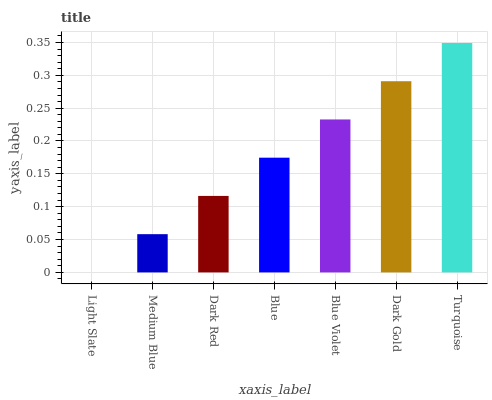Is Light Slate the minimum?
Answer yes or no. Yes. Is Turquoise the maximum?
Answer yes or no. Yes. Is Medium Blue the minimum?
Answer yes or no. No. Is Medium Blue the maximum?
Answer yes or no. No. Is Medium Blue greater than Light Slate?
Answer yes or no. Yes. Is Light Slate less than Medium Blue?
Answer yes or no. Yes. Is Light Slate greater than Medium Blue?
Answer yes or no. No. Is Medium Blue less than Light Slate?
Answer yes or no. No. Is Blue the high median?
Answer yes or no. Yes. Is Blue the low median?
Answer yes or no. Yes. Is Medium Blue the high median?
Answer yes or no. No. Is Medium Blue the low median?
Answer yes or no. No. 